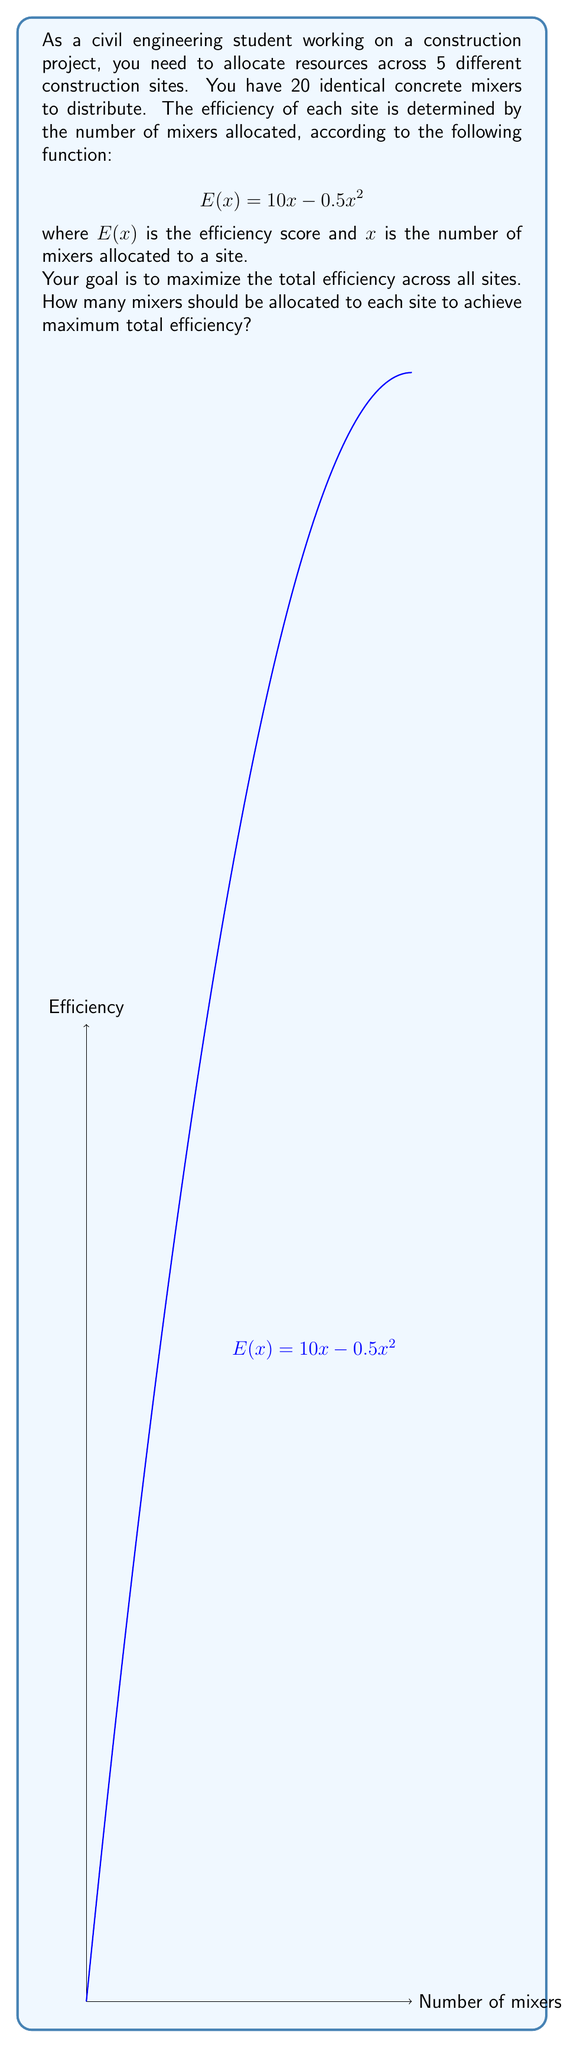Can you solve this math problem? Let's approach this step-by-step:

1) First, we need to understand that this is a constrained optimization problem. We want to maximize the total efficiency subject to the constraint that the sum of mixers across all sites is 20.

2) The key insight is that for maximum total efficiency, the marginal efficiency of adding a mixer should be equal across all sites. If it weren't, we could improve by moving a mixer from a lower marginal efficiency site to a higher one.

3) To find the marginal efficiency, we take the derivative of $E(x)$:

   $$E'(x) = 10 - x$$

4) Setting this equal across all sites:

   $$10 - x_1 = 10 - x_2 = 10 - x_3 = 10 - x_4 = 10 - x_5$$

5) This implies that $x_1 = x_2 = x_3 = x_4 = x_5$. Let's call this common value $x$.

6) Given our constraint:

   $$x_1 + x_2 + x_3 + x_4 + x_5 = 20$$
   $$5x = 20$$
   $$x = 4$$

7) Therefore, the optimal allocation is to assign 4 mixers to each of the 5 sites.

8) We can verify this is a maximum by checking the second derivative:

   $$E''(x) = -1 < 0$$

   This confirms we have found a maximum, not a minimum.
Answer: 4 mixers to each of the 5 sites 